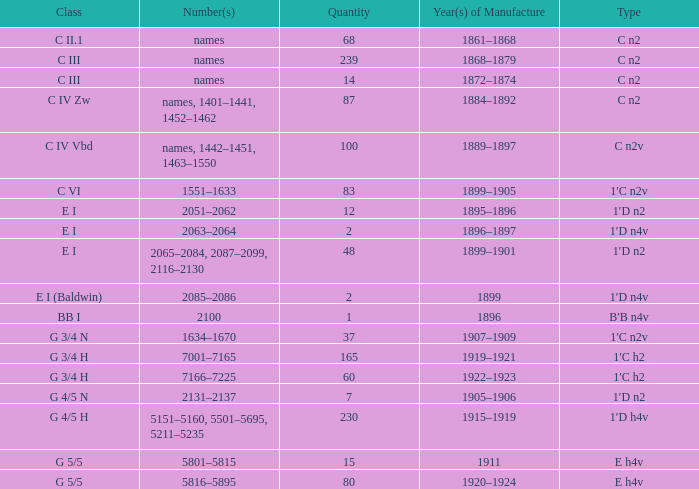Which product features an e h4v category and was produced during the 1920-1924 period? 80.0. 